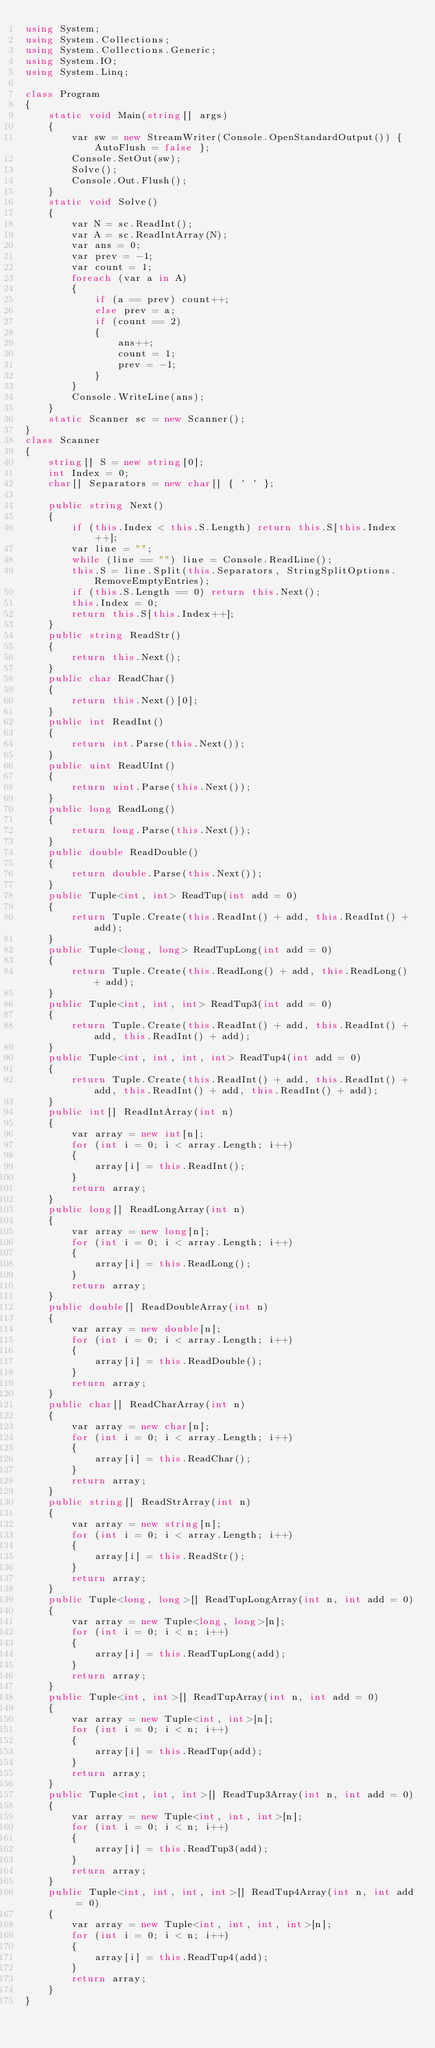Convert code to text. <code><loc_0><loc_0><loc_500><loc_500><_C#_>using System;
using System.Collections;
using System.Collections.Generic;
using System.IO;
using System.Linq;

class Program
{
    static void Main(string[] args)
    {
        var sw = new StreamWriter(Console.OpenStandardOutput()) { AutoFlush = false };
        Console.SetOut(sw);
        Solve();
        Console.Out.Flush();
    }
    static void Solve()
    {
        var N = sc.ReadInt();
        var A = sc.ReadIntArray(N);
        var ans = 0;
        var prev = -1;
        var count = 1;
        foreach (var a in A)
        {
            if (a == prev) count++;
            else prev = a;
            if (count == 2)
            {
                ans++;
                count = 1;
                prev = -1;
            }
        }
        Console.WriteLine(ans);
    }
    static Scanner sc = new Scanner();
}
class Scanner
{
    string[] S = new string[0];
    int Index = 0;
    char[] Separators = new char[] { ' ' };

    public string Next()
    {
        if (this.Index < this.S.Length) return this.S[this.Index++];
        var line = "";
        while (line == "") line = Console.ReadLine();
        this.S = line.Split(this.Separators, StringSplitOptions.RemoveEmptyEntries);
        if (this.S.Length == 0) return this.Next();
        this.Index = 0;
        return this.S[this.Index++];
    }
    public string ReadStr()
    {
        return this.Next();
    }
    public char ReadChar()
    {
        return this.Next()[0];
    }
    public int ReadInt()
    {
        return int.Parse(this.Next());
    }
    public uint ReadUInt()
    {
        return uint.Parse(this.Next());
    }
    public long ReadLong()
    {
        return long.Parse(this.Next());
    }
    public double ReadDouble()
    {
        return double.Parse(this.Next());
    }
    public Tuple<int, int> ReadTup(int add = 0)
    {
        return Tuple.Create(this.ReadInt() + add, this.ReadInt() + add);
    }
    public Tuple<long, long> ReadTupLong(int add = 0)
    {
        return Tuple.Create(this.ReadLong() + add, this.ReadLong() + add);
    }
    public Tuple<int, int, int> ReadTup3(int add = 0)
    {
        return Tuple.Create(this.ReadInt() + add, this.ReadInt() + add, this.ReadInt() + add);
    }
    public Tuple<int, int, int, int> ReadTup4(int add = 0)
    {
        return Tuple.Create(this.ReadInt() + add, this.ReadInt() + add, this.ReadInt() + add, this.ReadInt() + add);
    }
    public int[] ReadIntArray(int n)
    {
        var array = new int[n];
        for (int i = 0; i < array.Length; i++)
        {
            array[i] = this.ReadInt();
        }
        return array;
    }
    public long[] ReadLongArray(int n)
    {
        var array = new long[n];
        for (int i = 0; i < array.Length; i++)
        {
            array[i] = this.ReadLong();
        }
        return array;
    }
    public double[] ReadDoubleArray(int n)
    {
        var array = new double[n];
        for (int i = 0; i < array.Length; i++)
        {
            array[i] = this.ReadDouble();
        }
        return array;
    }
    public char[] ReadCharArray(int n)
    {
        var array = new char[n];
        for (int i = 0; i < array.Length; i++)
        {
            array[i] = this.ReadChar();
        }
        return array;
    }
    public string[] ReadStrArray(int n)
    {
        var array = new string[n];
        for (int i = 0; i < array.Length; i++)
        {
            array[i] = this.ReadStr();
        }
        return array;
    }
    public Tuple<long, long>[] ReadTupLongArray(int n, int add = 0)
    {
        var array = new Tuple<long, long>[n];
        for (int i = 0; i < n; i++)
        {
            array[i] = this.ReadTupLong(add);
        }
        return array;
    }
    public Tuple<int, int>[] ReadTupArray(int n, int add = 0)
    {
        var array = new Tuple<int, int>[n];
        for (int i = 0; i < n; i++)
        {
            array[i] = this.ReadTup(add);
        }
        return array;
    }
    public Tuple<int, int, int>[] ReadTup3Array(int n, int add = 0)
    {
        var array = new Tuple<int, int, int>[n];
        for (int i = 0; i < n; i++)
        {
            array[i] = this.ReadTup3(add);
        }
        return array;
    }
    public Tuple<int, int, int, int>[] ReadTup4Array(int n, int add = 0)
    {
        var array = new Tuple<int, int, int, int>[n];
        for (int i = 0; i < n; i++)
        {
            array[i] = this.ReadTup4(add);
        }
        return array;
    }
}
</code> 